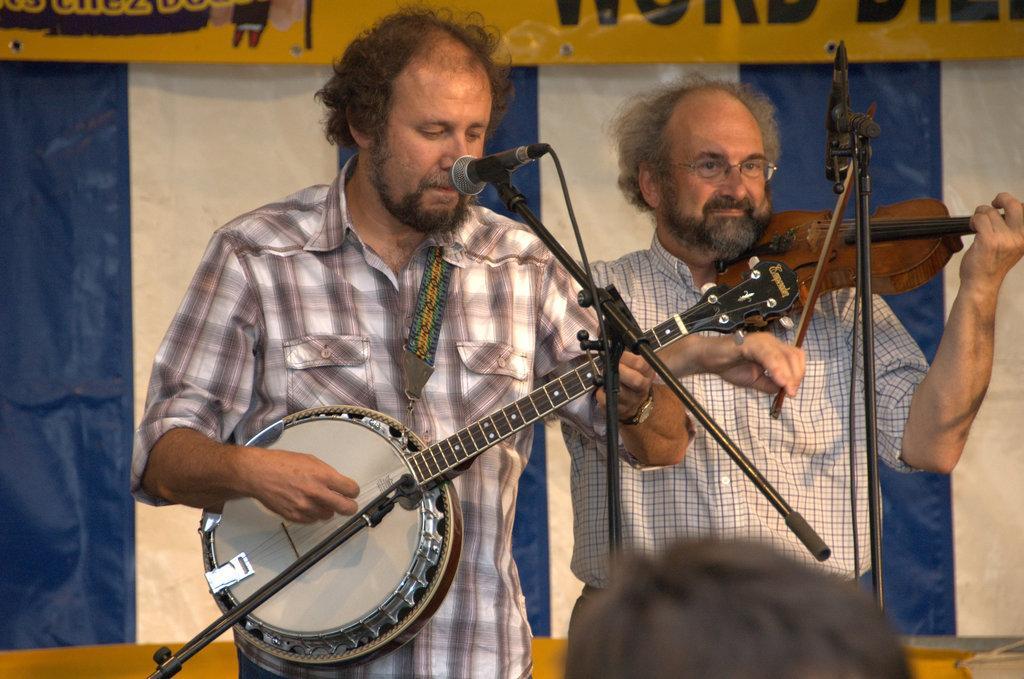Can you describe this image briefly? In the center of the image we can see a man is standing in-front of mic and playing a musical instrument. On the right side of the image we can see a man is standing and playing guitar and also we can see a mic with stand. In the background of the image we can see the curtain, banner. At the bottom of the image we can see a person head. 